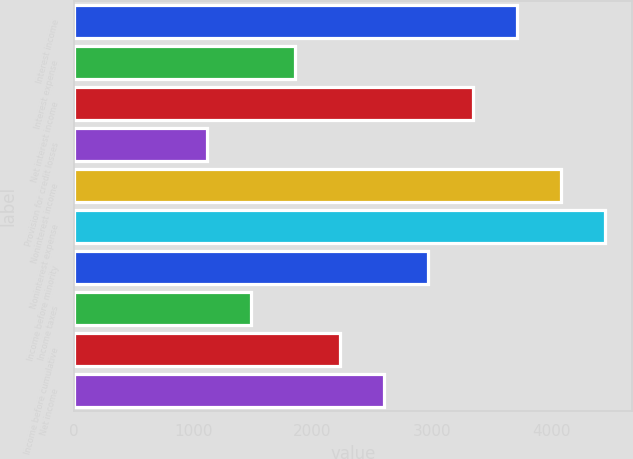Convert chart to OTSL. <chart><loc_0><loc_0><loc_500><loc_500><bar_chart><fcel>Interest income<fcel>Interest expense<fcel>Net interest income<fcel>Provision for credit losses<fcel>Noninterest income<fcel>Noninterest expense<fcel>Income before minority<fcel>Income taxes<fcel>Income before cumulative<fcel>Net income<nl><fcel>3712<fcel>1857<fcel>3341<fcel>1115<fcel>4083<fcel>4454<fcel>2970<fcel>1486<fcel>2228<fcel>2599<nl></chart> 